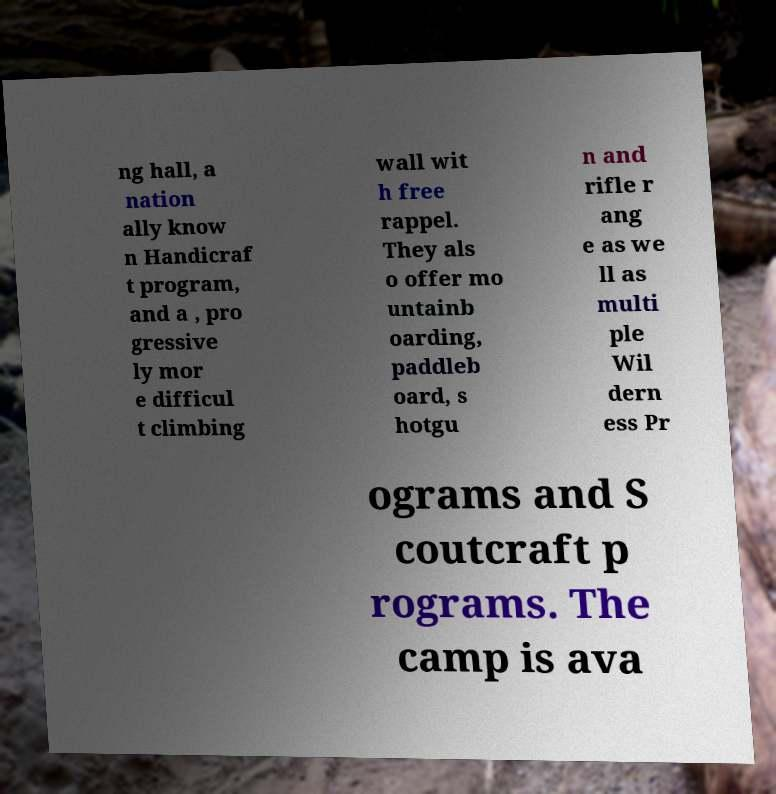There's text embedded in this image that I need extracted. Can you transcribe it verbatim? ng hall, a nation ally know n Handicraf t program, and a , pro gressive ly mor e difficul t climbing wall wit h free rappel. They als o offer mo untainb oarding, paddleb oard, s hotgu n and rifle r ang e as we ll as multi ple Wil dern ess Pr ograms and S coutcraft p rograms. The camp is ava 